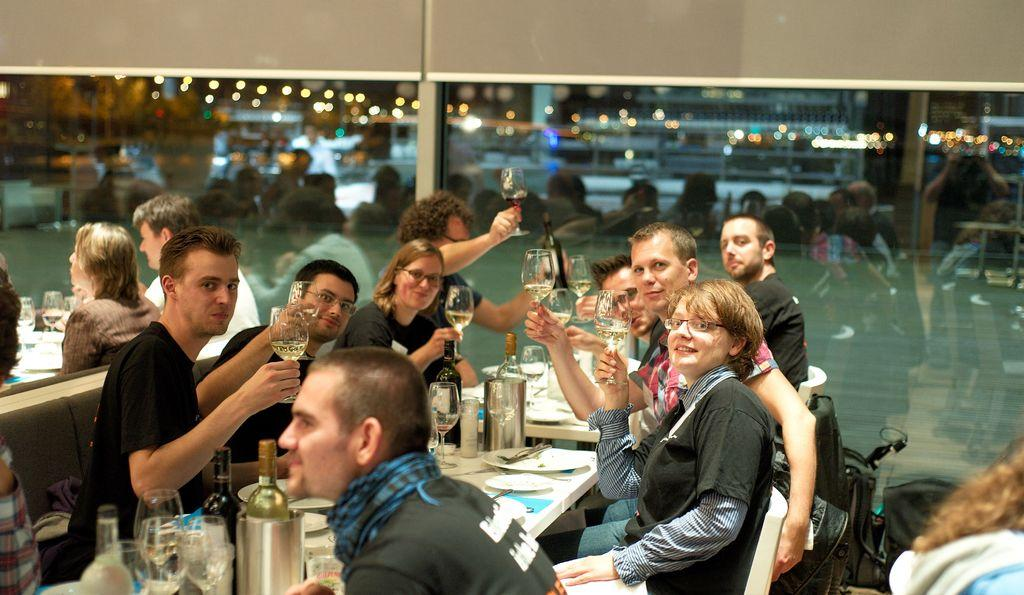What are the persons in the image doing? The persons in the image are sitting in chairs. What are the persons holding in their hands? The persons are holding a glass of wine. What is in front of the persons? There is a table in front of the persons. What can be found on the table? There are eatables and other objects on the table. What time of day is it in the image, considering the presence of a morning light? There is no mention of morning light or any specific time of day in the image. The image only shows persons sitting in chairs, holding a glass of wine, and a table with eatables and other objects. 